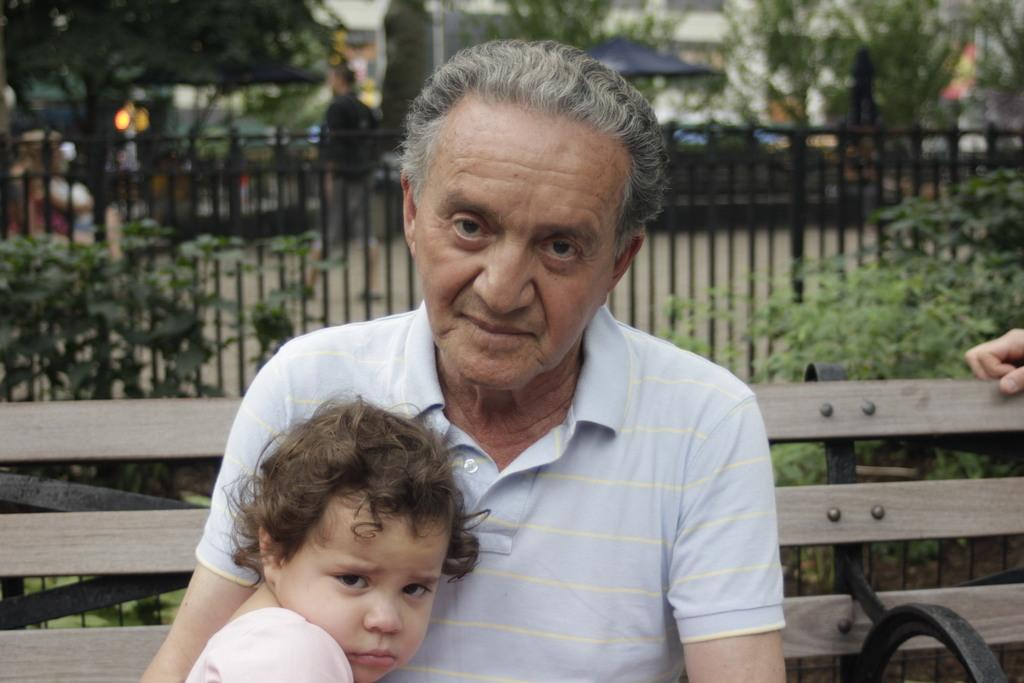Who is present in the image? There is a man and a kid in the image. What are the man and kid doing in the image? The man and kid are sitting on a bench. What can be seen in the background of the image? There is an iron railing, trees, and a person walking on the ground in the background of the image. What type of leather is visible on the bench in the image? There is no leather visible on the bench in the image; it is not mentioned in the provided facts. 